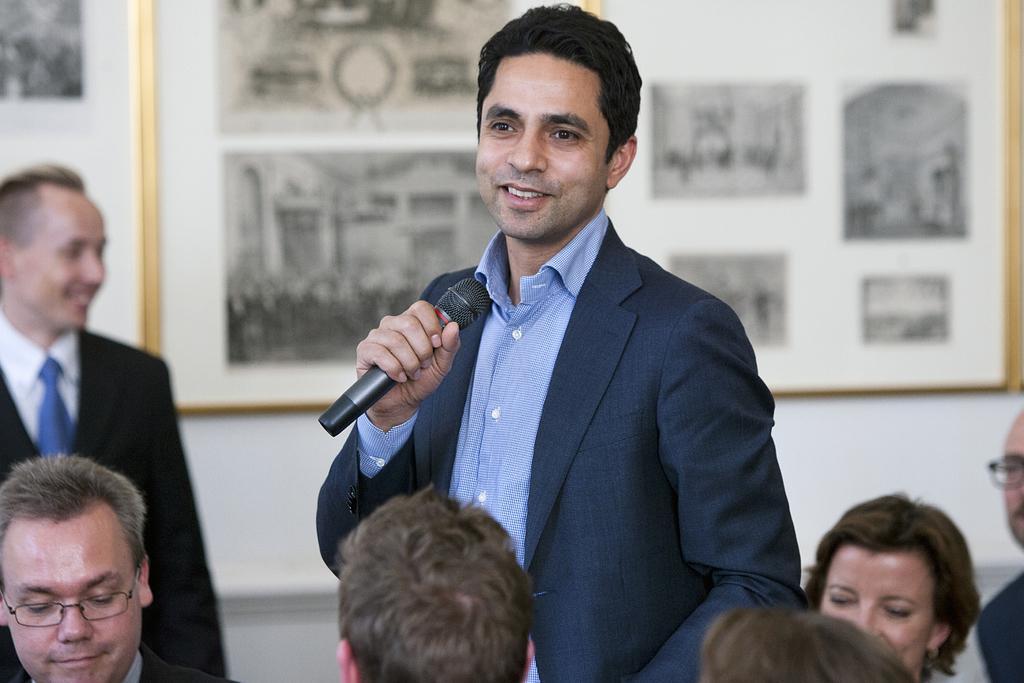Can you describe this image briefly? In the middle of the image a man is standing and holding a microphone and smiling. Behind him there is a wall, On the wall there is a frame. Bottom of the image few people are sitting. Bottom left side of the image a man is standing and smiling. 